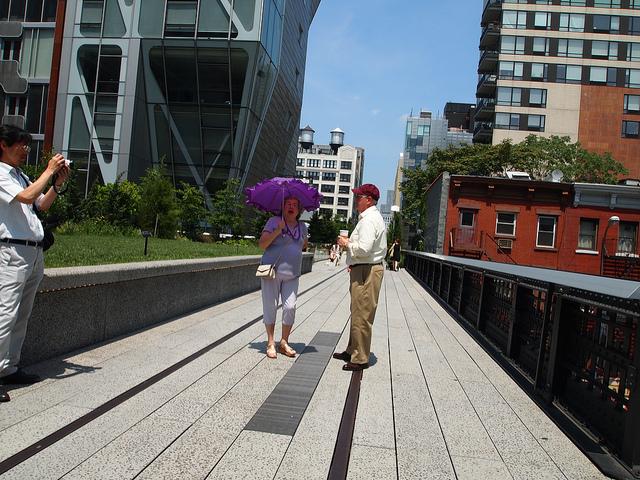Is it raining?
Be succinct. No. What  color is the umbrella?
Concise answer only. Purple. What is the weather like?
Keep it brief. Sunny. Who is holding the umbrella?
Write a very short answer. Woman. 